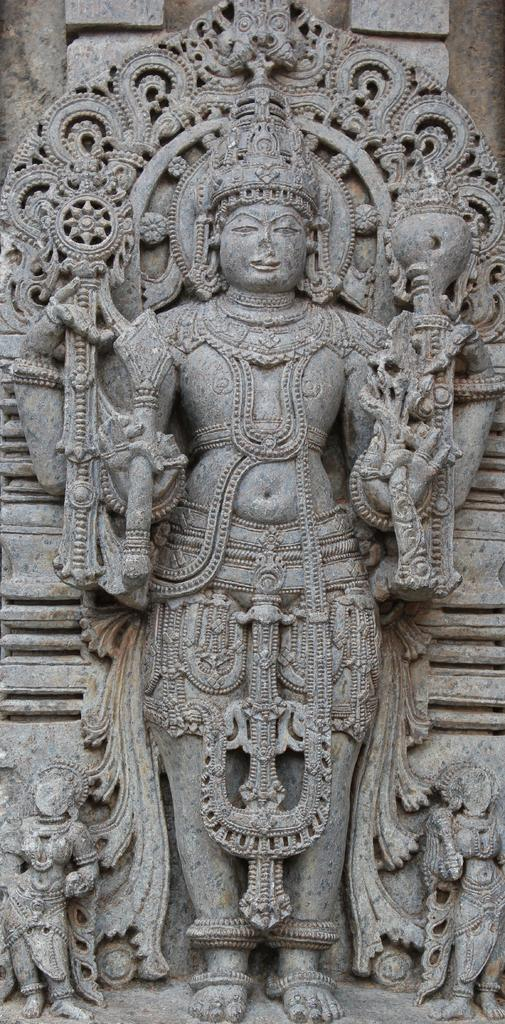What type of artwork can be seen on the wall in the image? There are sculptures on the wall in the image. Can you describe the sculptures in more detail? Unfortunately, the image does not provide enough detail to describe the sculptures further. What might be the purpose of having sculptures on the wall? The purpose of having sculptures on the wall could be for decoration or to convey a message or theme. What type of agreement was reached during the meeting depicted in the image? There is no meeting depicted in the image, only sculptures on the wall. How many knees are visible in the image? There are no knees visible in the image, only sculptures on the wall. 